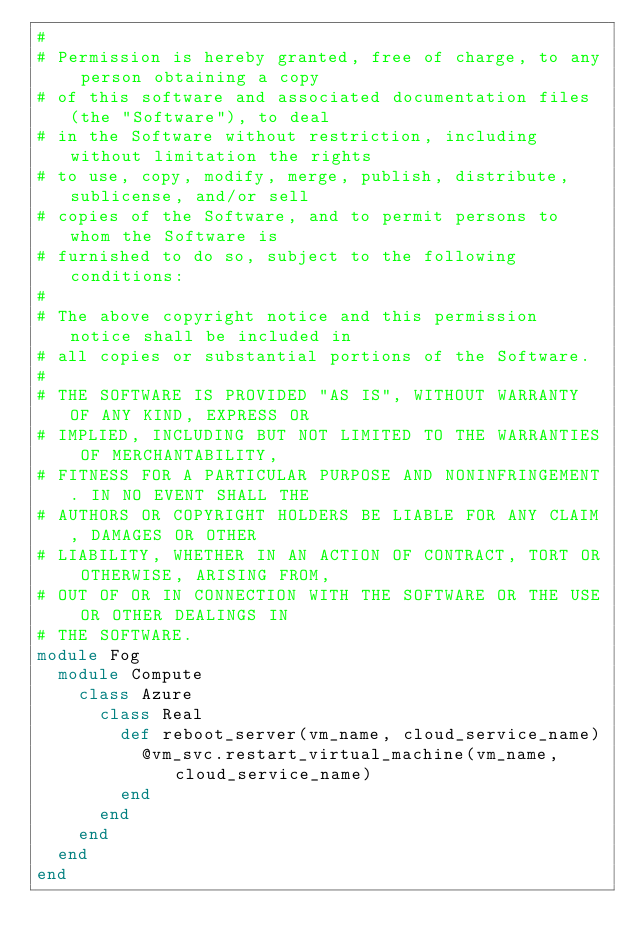Convert code to text. <code><loc_0><loc_0><loc_500><loc_500><_Ruby_>#
# Permission is hereby granted, free of charge, to any person obtaining a copy
# of this software and associated documentation files (the "Software"), to deal
# in the Software without restriction, including without limitation the rights
# to use, copy, modify, merge, publish, distribute, sublicense, and/or sell
# copies of the Software, and to permit persons to whom the Software is
# furnished to do so, subject to the following conditions:
#
# The above copyright notice and this permission notice shall be included in
# all copies or substantial portions of the Software.
#
# THE SOFTWARE IS PROVIDED "AS IS", WITHOUT WARRANTY OF ANY KIND, EXPRESS OR
# IMPLIED, INCLUDING BUT NOT LIMITED TO THE WARRANTIES OF MERCHANTABILITY,
# FITNESS FOR A PARTICULAR PURPOSE AND NONINFRINGEMENT. IN NO EVENT SHALL THE
# AUTHORS OR COPYRIGHT HOLDERS BE LIABLE FOR ANY CLAIM, DAMAGES OR OTHER
# LIABILITY, WHETHER IN AN ACTION OF CONTRACT, TORT OR OTHERWISE, ARISING FROM,
# OUT OF OR IN CONNECTION WITH THE SOFTWARE OR THE USE OR OTHER DEALINGS IN
# THE SOFTWARE.
module Fog
  module Compute
    class Azure
      class Real
        def reboot_server(vm_name, cloud_service_name)
          @vm_svc.restart_virtual_machine(vm_name, cloud_service_name)
        end
      end
    end
  end
end
</code> 